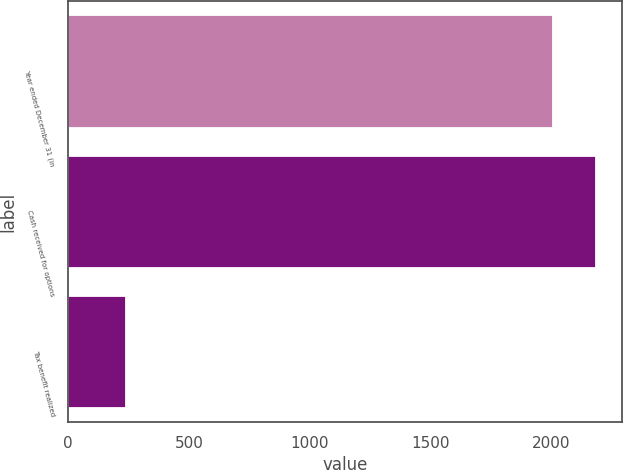<chart> <loc_0><loc_0><loc_500><loc_500><bar_chart><fcel>Year ended December 31 (in<fcel>Cash received for options<fcel>Tax benefit realized<nl><fcel>2007<fcel>2185.5<fcel>238<nl></chart> 